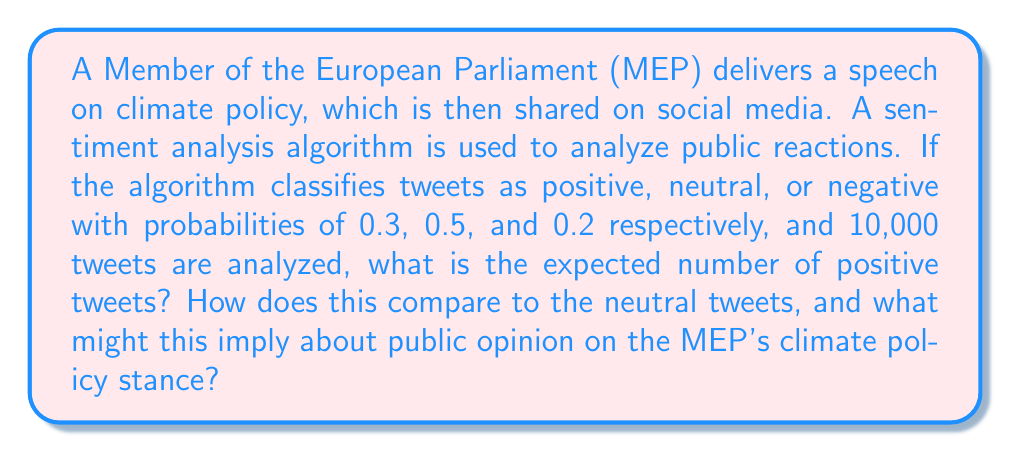Can you answer this question? To solve this problem, we'll follow these steps:

1. Calculate the expected number of positive tweets:
   The probability of a positive tweet is 0.3, and we have 10,000 tweets in total.
   Expected number of positive tweets = $0.3 \times 10,000 = 3,000$

2. Calculate the expected number of neutral tweets:
   The probability of a neutral tweet is 0.5.
   Expected number of neutral tweets = $0.5 \times 10,000 = 5,000$

3. Compare positive to neutral tweets:
   Ratio of positive to neutral = $\frac{3,000}{5,000} = 0.6$

4. Interpret the results:
   The expected number of positive tweets (3,000) is less than the expected number of neutral tweets (5,000). The ratio of 0.6 indicates that for every 10 neutral tweets, we expect to see 6 positive tweets.

This implies that while there is some positive sentiment towards the MEP's climate policy stance, the majority of the public remains neutral. As an interpreter, it's important to convey this nuanced reception to the MEP, noting that while there is support, there's also a significant portion of the audience that hasn't been swayed in either direction.
Answer: 3,000 positive tweets; ratio to neutral is 0.6, indicating moderate support with significant neutral sentiment. 